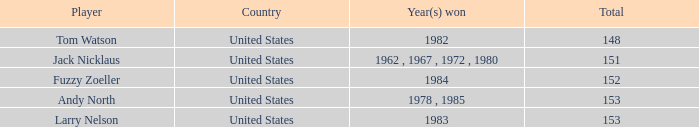What is the To par of Player Andy North with a Total larger than 153? 0.0. 